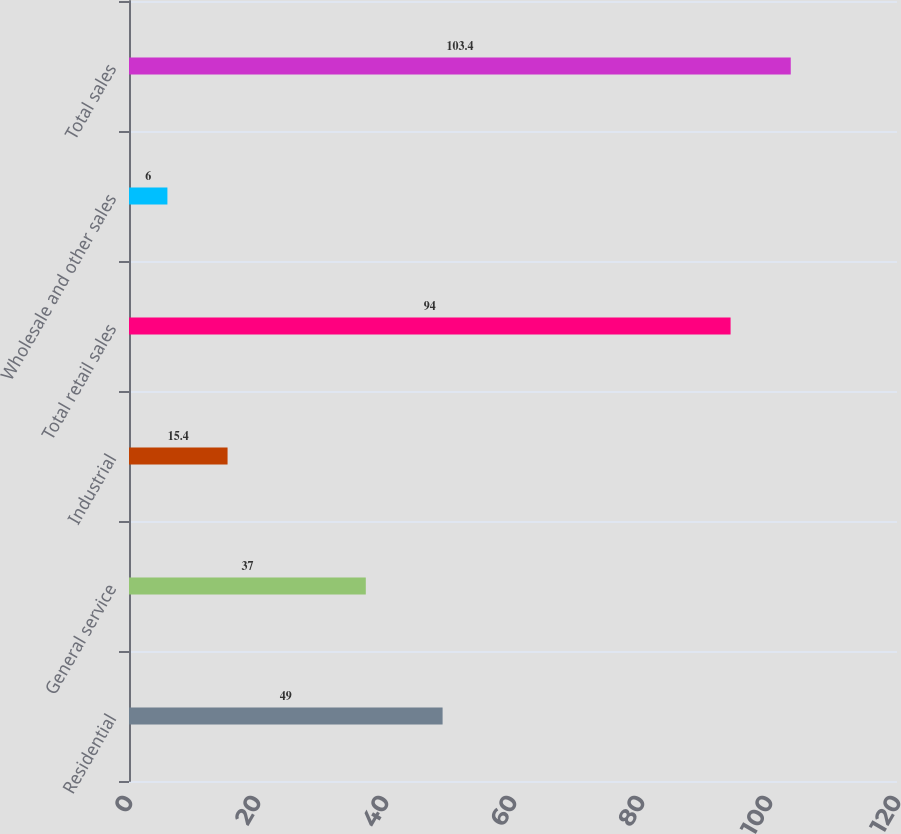<chart> <loc_0><loc_0><loc_500><loc_500><bar_chart><fcel>Residential<fcel>General service<fcel>Industrial<fcel>Total retail sales<fcel>Wholesale and other sales<fcel>Total sales<nl><fcel>49<fcel>37<fcel>15.4<fcel>94<fcel>6<fcel>103.4<nl></chart> 